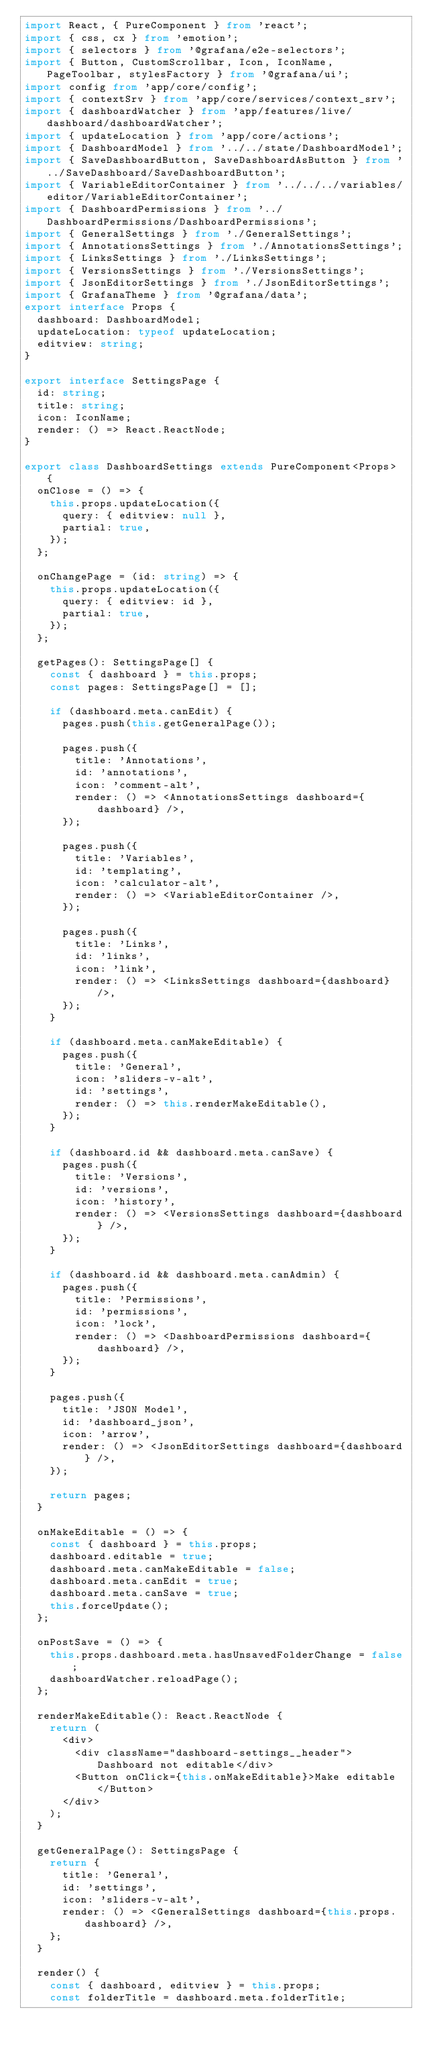<code> <loc_0><loc_0><loc_500><loc_500><_TypeScript_>import React, { PureComponent } from 'react';
import { css, cx } from 'emotion';
import { selectors } from '@grafana/e2e-selectors';
import { Button, CustomScrollbar, Icon, IconName, PageToolbar, stylesFactory } from '@grafana/ui';
import config from 'app/core/config';
import { contextSrv } from 'app/core/services/context_srv';
import { dashboardWatcher } from 'app/features/live/dashboard/dashboardWatcher';
import { updateLocation } from 'app/core/actions';
import { DashboardModel } from '../../state/DashboardModel';
import { SaveDashboardButton, SaveDashboardAsButton } from '../SaveDashboard/SaveDashboardButton';
import { VariableEditorContainer } from '../../../variables/editor/VariableEditorContainer';
import { DashboardPermissions } from '../DashboardPermissions/DashboardPermissions';
import { GeneralSettings } from './GeneralSettings';
import { AnnotationsSettings } from './AnnotationsSettings';
import { LinksSettings } from './LinksSettings';
import { VersionsSettings } from './VersionsSettings';
import { JsonEditorSettings } from './JsonEditorSettings';
import { GrafanaTheme } from '@grafana/data';
export interface Props {
  dashboard: DashboardModel;
  updateLocation: typeof updateLocation;
  editview: string;
}

export interface SettingsPage {
  id: string;
  title: string;
  icon: IconName;
  render: () => React.ReactNode;
}

export class DashboardSettings extends PureComponent<Props> {
  onClose = () => {
    this.props.updateLocation({
      query: { editview: null },
      partial: true,
    });
  };

  onChangePage = (id: string) => {
    this.props.updateLocation({
      query: { editview: id },
      partial: true,
    });
  };

  getPages(): SettingsPage[] {
    const { dashboard } = this.props;
    const pages: SettingsPage[] = [];

    if (dashboard.meta.canEdit) {
      pages.push(this.getGeneralPage());

      pages.push({
        title: 'Annotations',
        id: 'annotations',
        icon: 'comment-alt',
        render: () => <AnnotationsSettings dashboard={dashboard} />,
      });

      pages.push({
        title: 'Variables',
        id: 'templating',
        icon: 'calculator-alt',
        render: () => <VariableEditorContainer />,
      });

      pages.push({
        title: 'Links',
        id: 'links',
        icon: 'link',
        render: () => <LinksSettings dashboard={dashboard} />,
      });
    }

    if (dashboard.meta.canMakeEditable) {
      pages.push({
        title: 'General',
        icon: 'sliders-v-alt',
        id: 'settings',
        render: () => this.renderMakeEditable(),
      });
    }

    if (dashboard.id && dashboard.meta.canSave) {
      pages.push({
        title: 'Versions',
        id: 'versions',
        icon: 'history',
        render: () => <VersionsSettings dashboard={dashboard} />,
      });
    }

    if (dashboard.id && dashboard.meta.canAdmin) {
      pages.push({
        title: 'Permissions',
        id: 'permissions',
        icon: 'lock',
        render: () => <DashboardPermissions dashboard={dashboard} />,
      });
    }

    pages.push({
      title: 'JSON Model',
      id: 'dashboard_json',
      icon: 'arrow',
      render: () => <JsonEditorSettings dashboard={dashboard} />,
    });

    return pages;
  }

  onMakeEditable = () => {
    const { dashboard } = this.props;
    dashboard.editable = true;
    dashboard.meta.canMakeEditable = false;
    dashboard.meta.canEdit = true;
    dashboard.meta.canSave = true;
    this.forceUpdate();
  };

  onPostSave = () => {
    this.props.dashboard.meta.hasUnsavedFolderChange = false;
    dashboardWatcher.reloadPage();
  };

  renderMakeEditable(): React.ReactNode {
    return (
      <div>
        <div className="dashboard-settings__header">Dashboard not editable</div>
        <Button onClick={this.onMakeEditable}>Make editable</Button>
      </div>
    );
  }

  getGeneralPage(): SettingsPage {
    return {
      title: 'General',
      id: 'settings',
      icon: 'sliders-v-alt',
      render: () => <GeneralSettings dashboard={this.props.dashboard} />,
    };
  }

  render() {
    const { dashboard, editview } = this.props;
    const folderTitle = dashboard.meta.folderTitle;</code> 